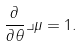<formula> <loc_0><loc_0><loc_500><loc_500>\frac { \partial } { \partial \theta } \lrcorner \mu = 1 .</formula> 